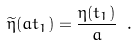Convert formula to latex. <formula><loc_0><loc_0><loc_500><loc_500>\widetilde { \eta } ( a t _ { 1 } ) = \frac { \eta ( t _ { 1 } ) } { a } \ .</formula> 